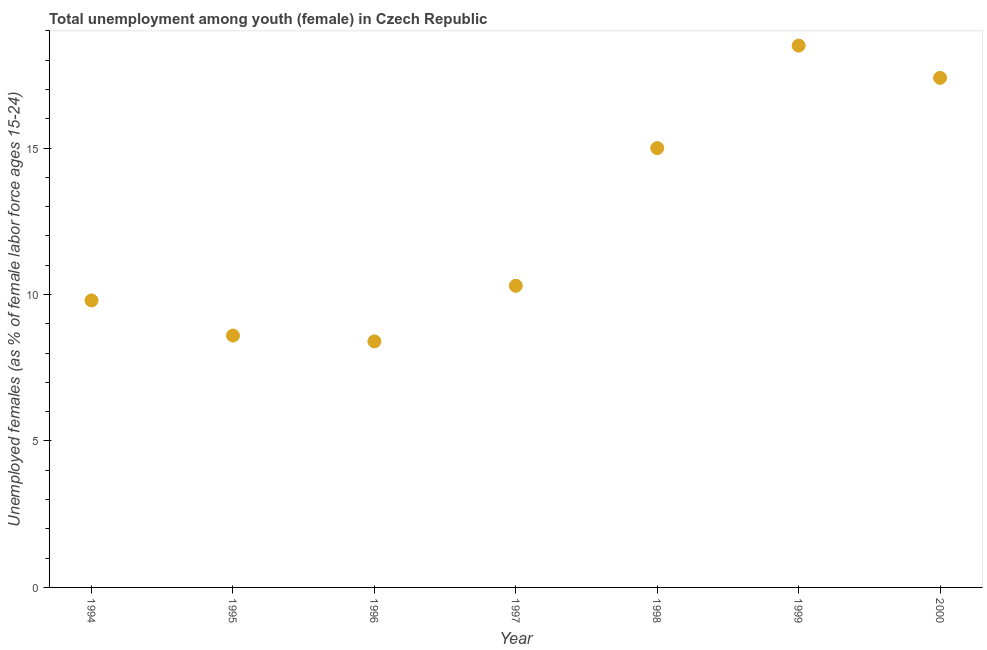What is the unemployed female youth population in 1996?
Give a very brief answer. 8.4. Across all years, what is the maximum unemployed female youth population?
Offer a very short reply. 18.5. Across all years, what is the minimum unemployed female youth population?
Ensure brevity in your answer.  8.4. What is the sum of the unemployed female youth population?
Keep it short and to the point. 88. What is the difference between the unemployed female youth population in 1995 and 1999?
Make the answer very short. -9.9. What is the average unemployed female youth population per year?
Ensure brevity in your answer.  12.57. What is the median unemployed female youth population?
Your answer should be very brief. 10.3. In how many years, is the unemployed female youth population greater than 5 %?
Give a very brief answer. 7. What is the ratio of the unemployed female youth population in 1995 to that in 2000?
Offer a very short reply. 0.49. Is the unemployed female youth population in 1994 less than that in 2000?
Your answer should be compact. Yes. Is the difference between the unemployed female youth population in 1994 and 1999 greater than the difference between any two years?
Your response must be concise. No. What is the difference between the highest and the second highest unemployed female youth population?
Your answer should be very brief. 1.1. What is the difference between the highest and the lowest unemployed female youth population?
Your answer should be compact. 10.1. In how many years, is the unemployed female youth population greater than the average unemployed female youth population taken over all years?
Keep it short and to the point. 3. How many years are there in the graph?
Offer a very short reply. 7. What is the difference between two consecutive major ticks on the Y-axis?
Keep it short and to the point. 5. Does the graph contain any zero values?
Offer a very short reply. No. What is the title of the graph?
Your answer should be compact. Total unemployment among youth (female) in Czech Republic. What is the label or title of the Y-axis?
Make the answer very short. Unemployed females (as % of female labor force ages 15-24). What is the Unemployed females (as % of female labor force ages 15-24) in 1994?
Provide a succinct answer. 9.8. What is the Unemployed females (as % of female labor force ages 15-24) in 1995?
Ensure brevity in your answer.  8.6. What is the Unemployed females (as % of female labor force ages 15-24) in 1996?
Ensure brevity in your answer.  8.4. What is the Unemployed females (as % of female labor force ages 15-24) in 1997?
Your response must be concise. 10.3. What is the Unemployed females (as % of female labor force ages 15-24) in 2000?
Offer a terse response. 17.4. What is the difference between the Unemployed females (as % of female labor force ages 15-24) in 1994 and 1995?
Make the answer very short. 1.2. What is the difference between the Unemployed females (as % of female labor force ages 15-24) in 1994 and 1996?
Ensure brevity in your answer.  1.4. What is the difference between the Unemployed females (as % of female labor force ages 15-24) in 1994 and 1997?
Your response must be concise. -0.5. What is the difference between the Unemployed females (as % of female labor force ages 15-24) in 1994 and 1998?
Offer a terse response. -5.2. What is the difference between the Unemployed females (as % of female labor force ages 15-24) in 1995 and 1996?
Ensure brevity in your answer.  0.2. What is the difference between the Unemployed females (as % of female labor force ages 15-24) in 1995 and 1998?
Your response must be concise. -6.4. What is the difference between the Unemployed females (as % of female labor force ages 15-24) in 1998 and 2000?
Give a very brief answer. -2.4. What is the ratio of the Unemployed females (as % of female labor force ages 15-24) in 1994 to that in 1995?
Make the answer very short. 1.14. What is the ratio of the Unemployed females (as % of female labor force ages 15-24) in 1994 to that in 1996?
Give a very brief answer. 1.17. What is the ratio of the Unemployed females (as % of female labor force ages 15-24) in 1994 to that in 1997?
Keep it short and to the point. 0.95. What is the ratio of the Unemployed females (as % of female labor force ages 15-24) in 1994 to that in 1998?
Your answer should be very brief. 0.65. What is the ratio of the Unemployed females (as % of female labor force ages 15-24) in 1994 to that in 1999?
Offer a very short reply. 0.53. What is the ratio of the Unemployed females (as % of female labor force ages 15-24) in 1994 to that in 2000?
Offer a terse response. 0.56. What is the ratio of the Unemployed females (as % of female labor force ages 15-24) in 1995 to that in 1997?
Provide a succinct answer. 0.83. What is the ratio of the Unemployed females (as % of female labor force ages 15-24) in 1995 to that in 1998?
Make the answer very short. 0.57. What is the ratio of the Unemployed females (as % of female labor force ages 15-24) in 1995 to that in 1999?
Your answer should be compact. 0.47. What is the ratio of the Unemployed females (as % of female labor force ages 15-24) in 1995 to that in 2000?
Offer a terse response. 0.49. What is the ratio of the Unemployed females (as % of female labor force ages 15-24) in 1996 to that in 1997?
Give a very brief answer. 0.82. What is the ratio of the Unemployed females (as % of female labor force ages 15-24) in 1996 to that in 1998?
Offer a terse response. 0.56. What is the ratio of the Unemployed females (as % of female labor force ages 15-24) in 1996 to that in 1999?
Provide a succinct answer. 0.45. What is the ratio of the Unemployed females (as % of female labor force ages 15-24) in 1996 to that in 2000?
Make the answer very short. 0.48. What is the ratio of the Unemployed females (as % of female labor force ages 15-24) in 1997 to that in 1998?
Provide a succinct answer. 0.69. What is the ratio of the Unemployed females (as % of female labor force ages 15-24) in 1997 to that in 1999?
Provide a succinct answer. 0.56. What is the ratio of the Unemployed females (as % of female labor force ages 15-24) in 1997 to that in 2000?
Provide a succinct answer. 0.59. What is the ratio of the Unemployed females (as % of female labor force ages 15-24) in 1998 to that in 1999?
Provide a succinct answer. 0.81. What is the ratio of the Unemployed females (as % of female labor force ages 15-24) in 1998 to that in 2000?
Your answer should be very brief. 0.86. What is the ratio of the Unemployed females (as % of female labor force ages 15-24) in 1999 to that in 2000?
Ensure brevity in your answer.  1.06. 